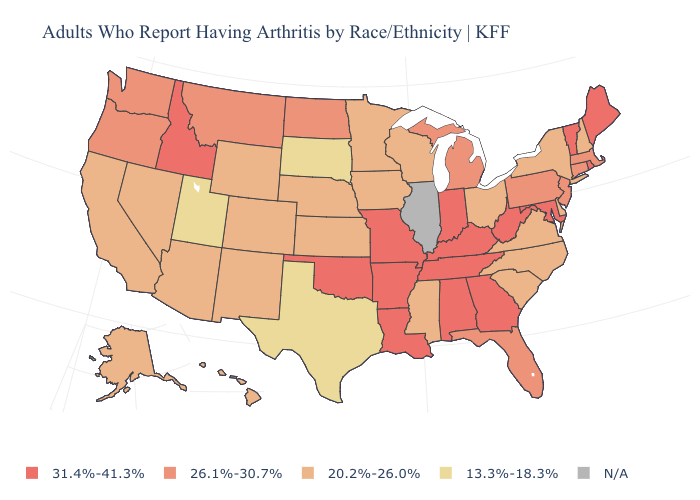Which states have the highest value in the USA?
Give a very brief answer. Alabama, Arkansas, Georgia, Idaho, Indiana, Kentucky, Louisiana, Maine, Maryland, Missouri, Oklahoma, Rhode Island, Tennessee, Vermont, West Virginia. What is the value of New Jersey?
Answer briefly. 26.1%-30.7%. Does Oregon have the lowest value in the USA?
Short answer required. No. What is the value of Idaho?
Write a very short answer. 31.4%-41.3%. Does New Hampshire have the lowest value in the Northeast?
Be succinct. Yes. What is the highest value in states that border Colorado?
Write a very short answer. 31.4%-41.3%. What is the value of South Dakota?
Quick response, please. 13.3%-18.3%. Name the states that have a value in the range N/A?
Short answer required. Illinois. What is the value of Montana?
Give a very brief answer. 26.1%-30.7%. What is the value of Maine?
Give a very brief answer. 31.4%-41.3%. Name the states that have a value in the range N/A?
Answer briefly. Illinois. Which states hav the highest value in the South?
Quick response, please. Alabama, Arkansas, Georgia, Kentucky, Louisiana, Maryland, Oklahoma, Tennessee, West Virginia. What is the highest value in the South ?
Short answer required. 31.4%-41.3%. Does the first symbol in the legend represent the smallest category?
Give a very brief answer. No. 